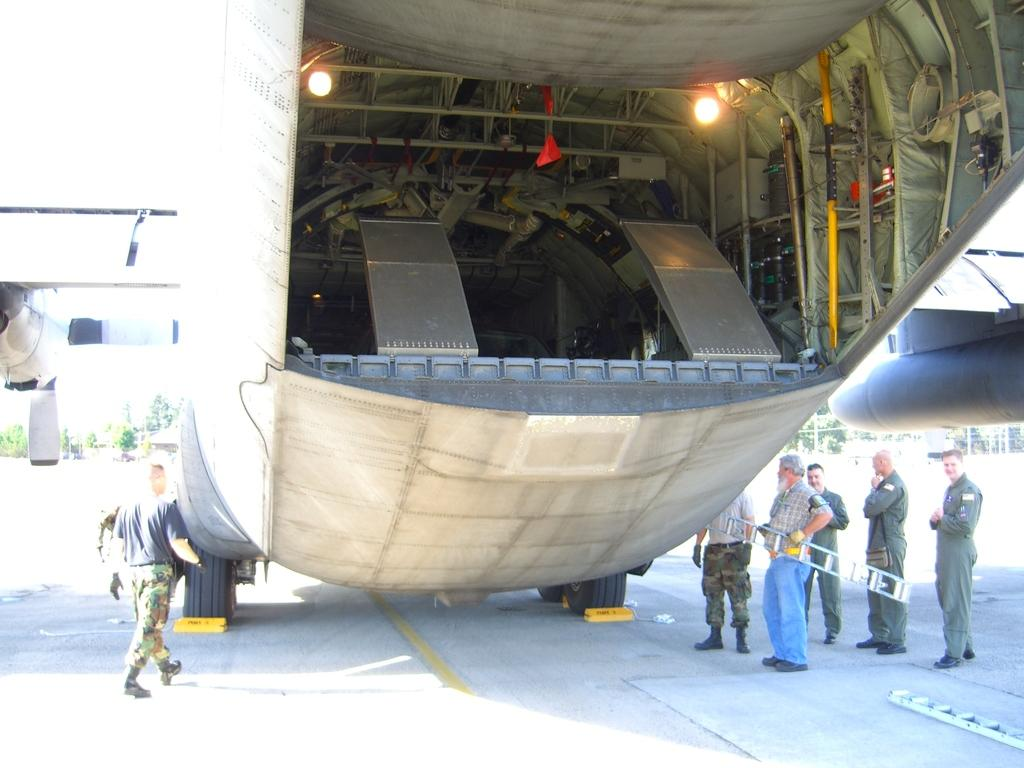What type of motor vehicle is on the road in the image? There is a motor vehicle on the road in the image, but the specific type is not mentioned. What are the people on the road doing? There are people standing on the road, and one person is holding a ladder. What can be seen in the background of the image? Trees and the sky are visible in the image. Can you tell me how many brothers are standing near the harbor in the image? There is no harbor or mention of brothers in the image; it features a motor vehicle, people, a ladder, trees, and the sky. 